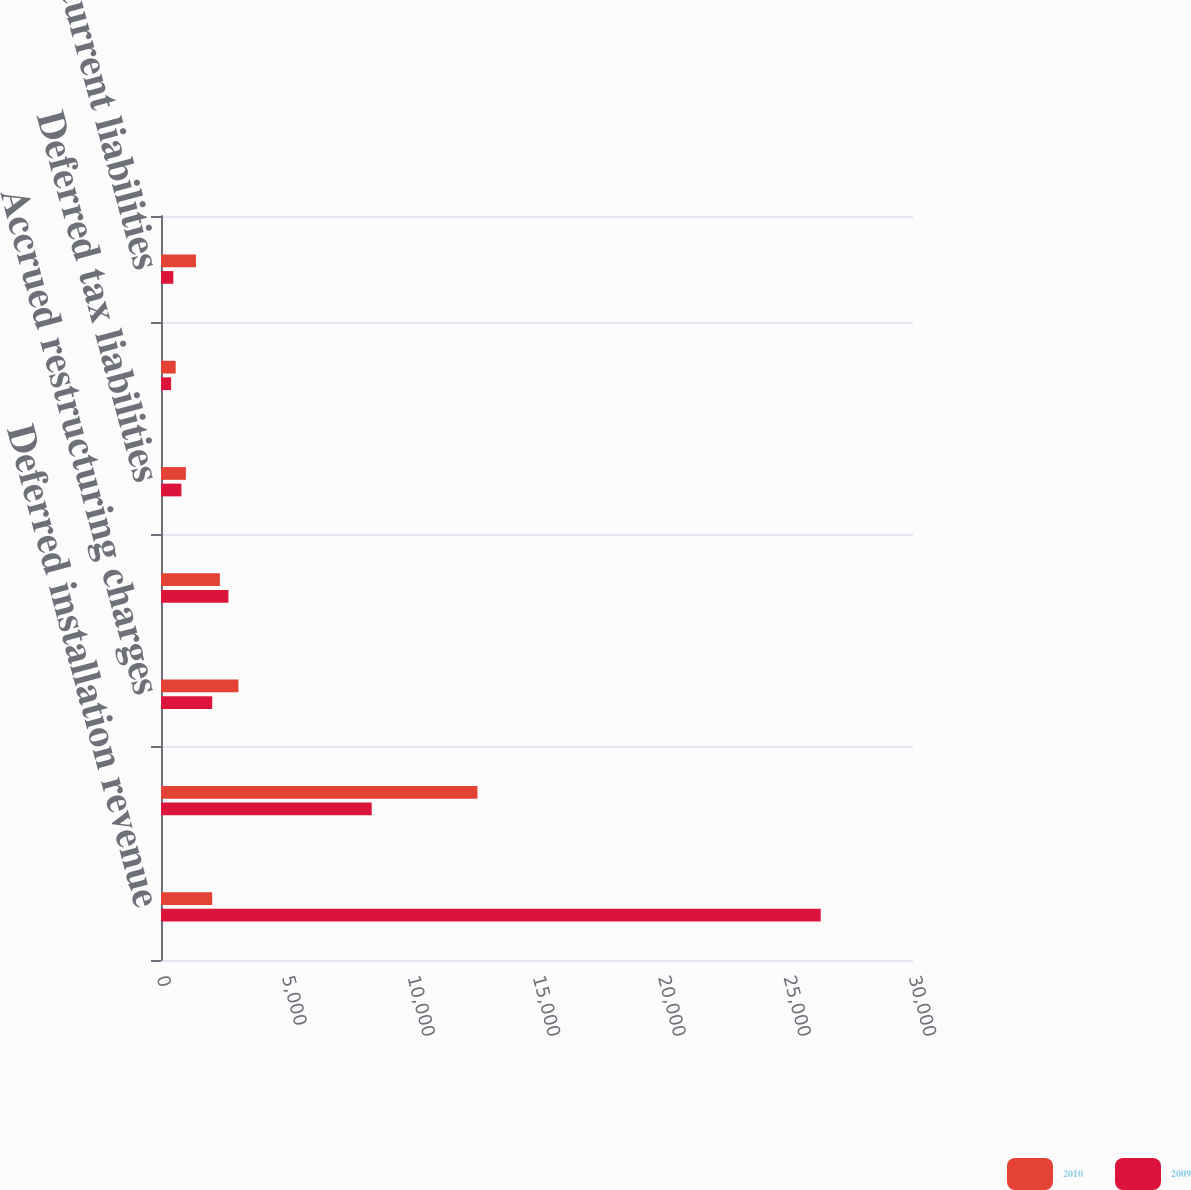<chart> <loc_0><loc_0><loc_500><loc_500><stacked_bar_chart><ecel><fcel>Deferred installation revenue<fcel>Customer deposits<fcel>Accrued restructuring charges<fcel>Deferred recurring revenue<fcel>Deferred tax liabilities<fcel>Deferred rent<fcel>Other current liabilities<nl><fcel>2010<fcel>2043<fcel>12624<fcel>3089<fcel>2349<fcel>993<fcel>585<fcel>1394<nl><fcel>2009<fcel>26319<fcel>8406<fcel>2043<fcel>2689<fcel>814<fcel>403<fcel>492<nl></chart> 